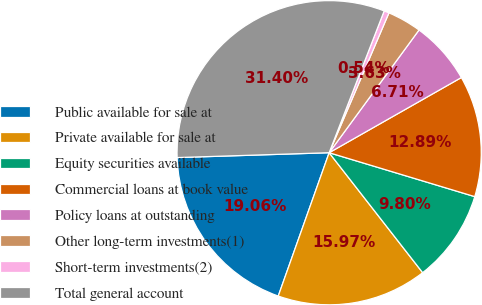Convert chart to OTSL. <chart><loc_0><loc_0><loc_500><loc_500><pie_chart><fcel>Public available for sale at<fcel>Private available for sale at<fcel>Equity securities available<fcel>Commercial loans at book value<fcel>Policy loans at outstanding<fcel>Other long-term investments(1)<fcel>Short-term investments(2)<fcel>Total general account<nl><fcel>19.06%<fcel>15.97%<fcel>9.8%<fcel>12.89%<fcel>6.71%<fcel>3.63%<fcel>0.54%<fcel>31.4%<nl></chart> 